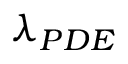<formula> <loc_0><loc_0><loc_500><loc_500>\lambda _ { P D E }</formula> 